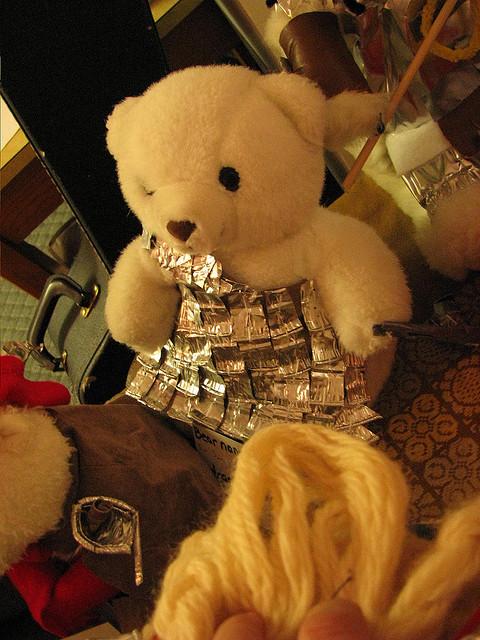Is the bear bigger than an adult person?
Keep it brief. No. Is the bear dressed appropriately for the prom?
Quick response, please. Yes. What kind of animal is this?
Quick response, please. Bear. 